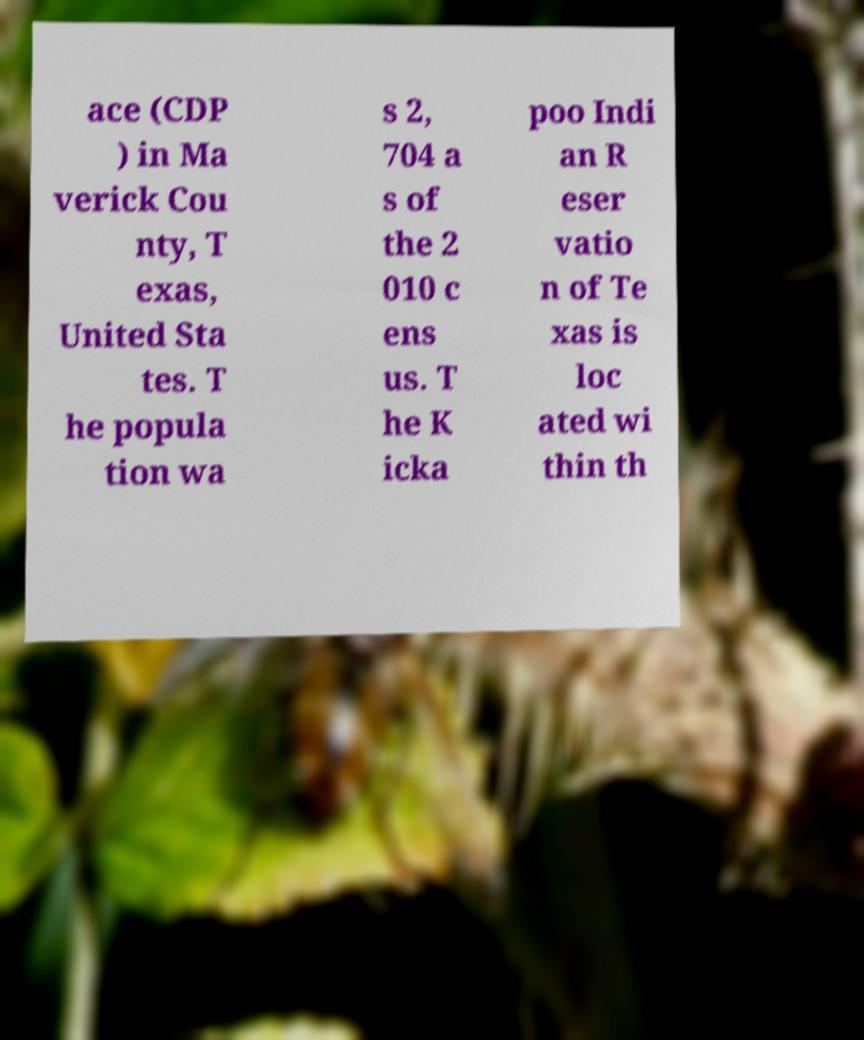Can you accurately transcribe the text from the provided image for me? ace (CDP ) in Ma verick Cou nty, T exas, United Sta tes. T he popula tion wa s 2, 704 a s of the 2 010 c ens us. T he K icka poo Indi an R eser vatio n of Te xas is loc ated wi thin th 